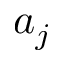Convert formula to latex. <formula><loc_0><loc_0><loc_500><loc_500>a _ { j }</formula> 